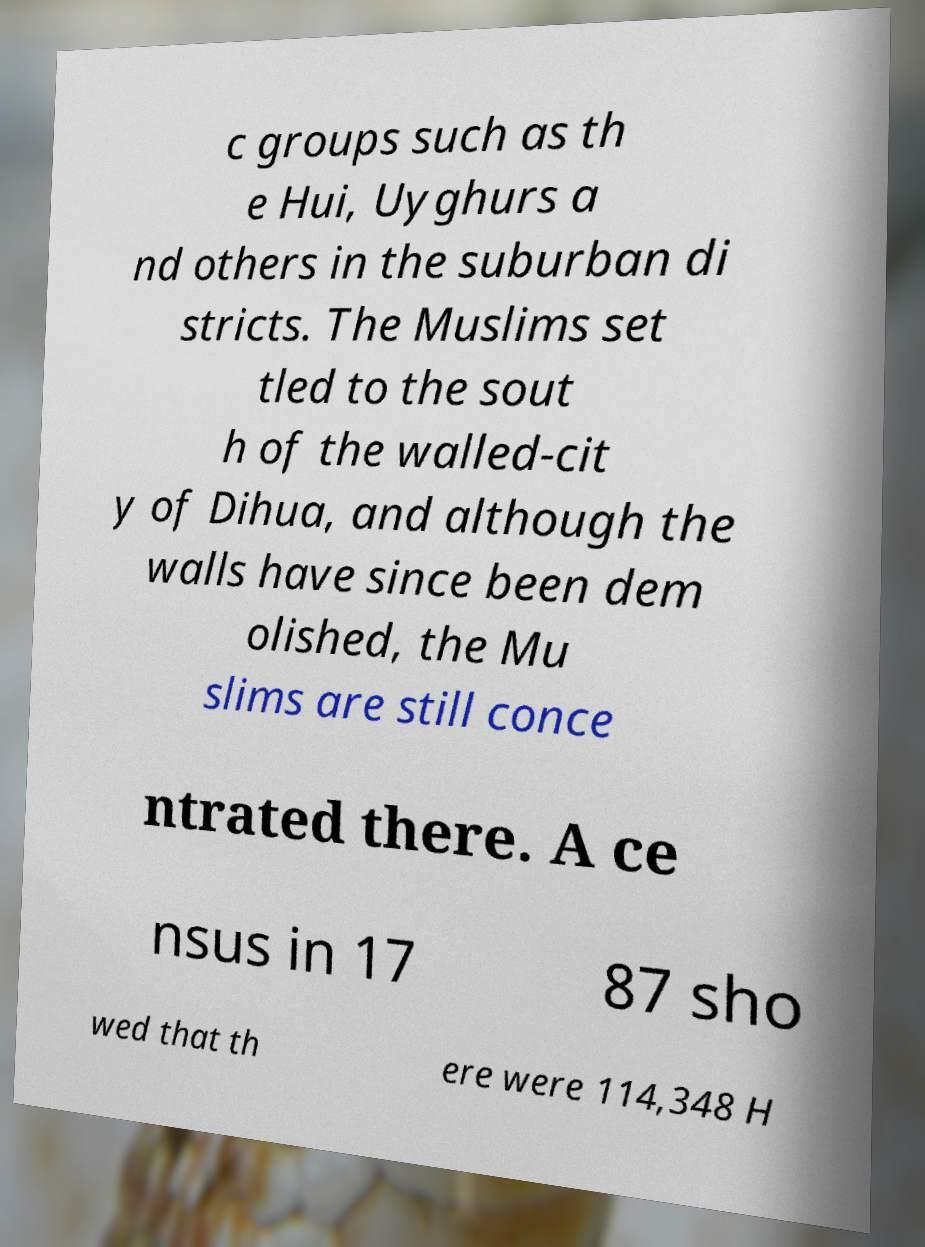What messages or text are displayed in this image? I need them in a readable, typed format. c groups such as th e Hui, Uyghurs a nd others in the suburban di stricts. The Muslims set tled to the sout h of the walled-cit y of Dihua, and although the walls have since been dem olished, the Mu slims are still conce ntrated there. A ce nsus in 17 87 sho wed that th ere were 114,348 H 